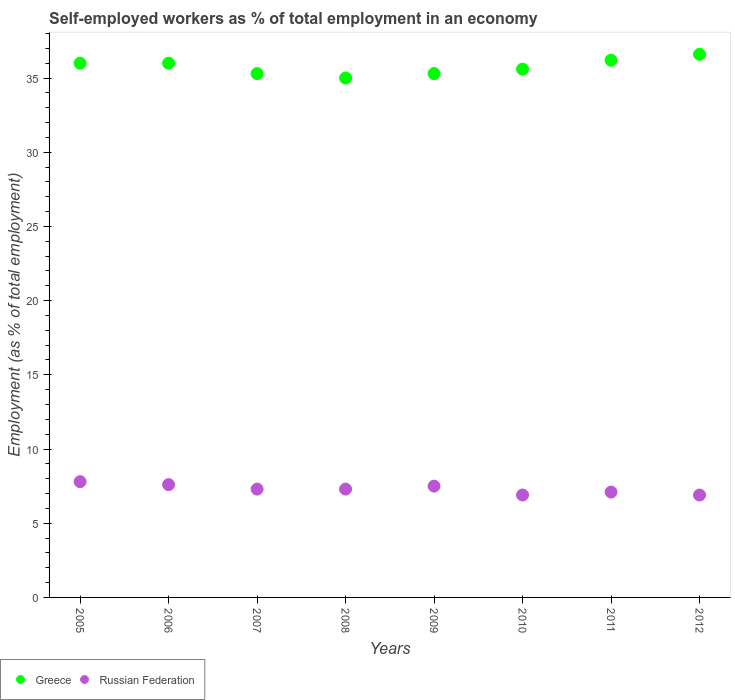How many different coloured dotlines are there?
Ensure brevity in your answer.  2. Is the number of dotlines equal to the number of legend labels?
Provide a short and direct response. Yes. What is the percentage of self-employed workers in Russian Federation in 2005?
Your response must be concise. 7.8. Across all years, what is the maximum percentage of self-employed workers in Russian Federation?
Offer a very short reply. 7.8. Across all years, what is the minimum percentage of self-employed workers in Greece?
Give a very brief answer. 35. In which year was the percentage of self-employed workers in Russian Federation minimum?
Give a very brief answer. 2010. What is the total percentage of self-employed workers in Greece in the graph?
Provide a succinct answer. 286. What is the difference between the percentage of self-employed workers in Russian Federation in 2007 and that in 2012?
Give a very brief answer. 0.4. What is the difference between the percentage of self-employed workers in Greece in 2011 and the percentage of self-employed workers in Russian Federation in 2009?
Provide a succinct answer. 28.7. What is the average percentage of self-employed workers in Greece per year?
Keep it short and to the point. 35.75. In the year 2009, what is the difference between the percentage of self-employed workers in Greece and percentage of self-employed workers in Russian Federation?
Keep it short and to the point. 27.8. In how many years, is the percentage of self-employed workers in Greece greater than 17 %?
Your answer should be very brief. 8. What is the ratio of the percentage of self-employed workers in Greece in 2005 to that in 2008?
Provide a succinct answer. 1.03. What is the difference between the highest and the second highest percentage of self-employed workers in Russian Federation?
Keep it short and to the point. 0.2. What is the difference between the highest and the lowest percentage of self-employed workers in Russian Federation?
Your response must be concise. 0.9. Does the percentage of self-employed workers in Russian Federation monotonically increase over the years?
Ensure brevity in your answer.  No. Is the percentage of self-employed workers in Greece strictly less than the percentage of self-employed workers in Russian Federation over the years?
Offer a very short reply. No. What is the difference between two consecutive major ticks on the Y-axis?
Make the answer very short. 5. Does the graph contain any zero values?
Provide a short and direct response. No. How are the legend labels stacked?
Provide a succinct answer. Horizontal. What is the title of the graph?
Offer a very short reply. Self-employed workers as % of total employment in an economy. Does "Djibouti" appear as one of the legend labels in the graph?
Make the answer very short. No. What is the label or title of the X-axis?
Your answer should be very brief. Years. What is the label or title of the Y-axis?
Give a very brief answer. Employment (as % of total employment). What is the Employment (as % of total employment) of Greece in 2005?
Provide a short and direct response. 36. What is the Employment (as % of total employment) of Russian Federation in 2005?
Give a very brief answer. 7.8. What is the Employment (as % of total employment) in Russian Federation in 2006?
Your response must be concise. 7.6. What is the Employment (as % of total employment) of Greece in 2007?
Provide a short and direct response. 35.3. What is the Employment (as % of total employment) of Russian Federation in 2007?
Your answer should be very brief. 7.3. What is the Employment (as % of total employment) of Greece in 2008?
Your answer should be compact. 35. What is the Employment (as % of total employment) of Russian Federation in 2008?
Keep it short and to the point. 7.3. What is the Employment (as % of total employment) of Greece in 2009?
Your answer should be compact. 35.3. What is the Employment (as % of total employment) in Greece in 2010?
Offer a very short reply. 35.6. What is the Employment (as % of total employment) of Russian Federation in 2010?
Your answer should be compact. 6.9. What is the Employment (as % of total employment) in Greece in 2011?
Offer a terse response. 36.2. What is the Employment (as % of total employment) in Russian Federation in 2011?
Give a very brief answer. 7.1. What is the Employment (as % of total employment) of Greece in 2012?
Offer a very short reply. 36.6. What is the Employment (as % of total employment) of Russian Federation in 2012?
Your answer should be compact. 6.9. Across all years, what is the maximum Employment (as % of total employment) in Greece?
Your answer should be compact. 36.6. Across all years, what is the maximum Employment (as % of total employment) in Russian Federation?
Your answer should be very brief. 7.8. Across all years, what is the minimum Employment (as % of total employment) in Russian Federation?
Offer a very short reply. 6.9. What is the total Employment (as % of total employment) in Greece in the graph?
Give a very brief answer. 286. What is the total Employment (as % of total employment) of Russian Federation in the graph?
Your response must be concise. 58.4. What is the difference between the Employment (as % of total employment) of Russian Federation in 2005 and that in 2006?
Offer a terse response. 0.2. What is the difference between the Employment (as % of total employment) in Russian Federation in 2005 and that in 2007?
Provide a succinct answer. 0.5. What is the difference between the Employment (as % of total employment) in Russian Federation in 2005 and that in 2008?
Offer a terse response. 0.5. What is the difference between the Employment (as % of total employment) of Greece in 2005 and that in 2009?
Keep it short and to the point. 0.7. What is the difference between the Employment (as % of total employment) of Russian Federation in 2005 and that in 2009?
Provide a succinct answer. 0.3. What is the difference between the Employment (as % of total employment) in Russian Federation in 2005 and that in 2010?
Your response must be concise. 0.9. What is the difference between the Employment (as % of total employment) of Russian Federation in 2005 and that in 2012?
Make the answer very short. 0.9. What is the difference between the Employment (as % of total employment) in Greece in 2006 and that in 2007?
Ensure brevity in your answer.  0.7. What is the difference between the Employment (as % of total employment) in Russian Federation in 2006 and that in 2007?
Offer a very short reply. 0.3. What is the difference between the Employment (as % of total employment) of Greece in 2006 and that in 2008?
Keep it short and to the point. 1. What is the difference between the Employment (as % of total employment) in Greece in 2006 and that in 2009?
Give a very brief answer. 0.7. What is the difference between the Employment (as % of total employment) in Russian Federation in 2006 and that in 2009?
Provide a short and direct response. 0.1. What is the difference between the Employment (as % of total employment) of Russian Federation in 2006 and that in 2010?
Ensure brevity in your answer.  0.7. What is the difference between the Employment (as % of total employment) in Greece in 2006 and that in 2011?
Your answer should be compact. -0.2. What is the difference between the Employment (as % of total employment) of Greece in 2006 and that in 2012?
Ensure brevity in your answer.  -0.6. What is the difference between the Employment (as % of total employment) in Russian Federation in 2006 and that in 2012?
Ensure brevity in your answer.  0.7. What is the difference between the Employment (as % of total employment) in Russian Federation in 2007 and that in 2010?
Offer a terse response. 0.4. What is the difference between the Employment (as % of total employment) of Greece in 2007 and that in 2011?
Your response must be concise. -0.9. What is the difference between the Employment (as % of total employment) in Russian Federation in 2007 and that in 2011?
Your answer should be compact. 0.2. What is the difference between the Employment (as % of total employment) in Russian Federation in 2007 and that in 2012?
Provide a succinct answer. 0.4. What is the difference between the Employment (as % of total employment) in Greece in 2008 and that in 2009?
Provide a succinct answer. -0.3. What is the difference between the Employment (as % of total employment) of Russian Federation in 2008 and that in 2009?
Your answer should be very brief. -0.2. What is the difference between the Employment (as % of total employment) of Greece in 2008 and that in 2011?
Ensure brevity in your answer.  -1.2. What is the difference between the Employment (as % of total employment) in Russian Federation in 2008 and that in 2011?
Provide a short and direct response. 0.2. What is the difference between the Employment (as % of total employment) in Greece in 2008 and that in 2012?
Ensure brevity in your answer.  -1.6. What is the difference between the Employment (as % of total employment) of Russian Federation in 2008 and that in 2012?
Make the answer very short. 0.4. What is the difference between the Employment (as % of total employment) of Greece in 2009 and that in 2010?
Ensure brevity in your answer.  -0.3. What is the difference between the Employment (as % of total employment) of Greece in 2009 and that in 2011?
Make the answer very short. -0.9. What is the difference between the Employment (as % of total employment) of Russian Federation in 2009 and that in 2011?
Give a very brief answer. 0.4. What is the difference between the Employment (as % of total employment) of Greece in 2009 and that in 2012?
Make the answer very short. -1.3. What is the difference between the Employment (as % of total employment) of Russian Federation in 2009 and that in 2012?
Your answer should be very brief. 0.6. What is the difference between the Employment (as % of total employment) of Greece in 2010 and that in 2011?
Make the answer very short. -0.6. What is the difference between the Employment (as % of total employment) in Russian Federation in 2010 and that in 2012?
Your answer should be very brief. 0. What is the difference between the Employment (as % of total employment) of Russian Federation in 2011 and that in 2012?
Offer a terse response. 0.2. What is the difference between the Employment (as % of total employment) of Greece in 2005 and the Employment (as % of total employment) of Russian Federation in 2006?
Give a very brief answer. 28.4. What is the difference between the Employment (as % of total employment) in Greece in 2005 and the Employment (as % of total employment) in Russian Federation in 2007?
Offer a terse response. 28.7. What is the difference between the Employment (as % of total employment) of Greece in 2005 and the Employment (as % of total employment) of Russian Federation in 2008?
Offer a terse response. 28.7. What is the difference between the Employment (as % of total employment) of Greece in 2005 and the Employment (as % of total employment) of Russian Federation in 2009?
Provide a succinct answer. 28.5. What is the difference between the Employment (as % of total employment) of Greece in 2005 and the Employment (as % of total employment) of Russian Federation in 2010?
Make the answer very short. 29.1. What is the difference between the Employment (as % of total employment) in Greece in 2005 and the Employment (as % of total employment) in Russian Federation in 2011?
Offer a very short reply. 28.9. What is the difference between the Employment (as % of total employment) in Greece in 2005 and the Employment (as % of total employment) in Russian Federation in 2012?
Offer a very short reply. 29.1. What is the difference between the Employment (as % of total employment) in Greece in 2006 and the Employment (as % of total employment) in Russian Federation in 2007?
Offer a terse response. 28.7. What is the difference between the Employment (as % of total employment) in Greece in 2006 and the Employment (as % of total employment) in Russian Federation in 2008?
Ensure brevity in your answer.  28.7. What is the difference between the Employment (as % of total employment) in Greece in 2006 and the Employment (as % of total employment) in Russian Federation in 2010?
Give a very brief answer. 29.1. What is the difference between the Employment (as % of total employment) in Greece in 2006 and the Employment (as % of total employment) in Russian Federation in 2011?
Your answer should be very brief. 28.9. What is the difference between the Employment (as % of total employment) of Greece in 2006 and the Employment (as % of total employment) of Russian Federation in 2012?
Provide a succinct answer. 29.1. What is the difference between the Employment (as % of total employment) in Greece in 2007 and the Employment (as % of total employment) in Russian Federation in 2009?
Make the answer very short. 27.8. What is the difference between the Employment (as % of total employment) in Greece in 2007 and the Employment (as % of total employment) in Russian Federation in 2010?
Ensure brevity in your answer.  28.4. What is the difference between the Employment (as % of total employment) of Greece in 2007 and the Employment (as % of total employment) of Russian Federation in 2011?
Offer a terse response. 28.2. What is the difference between the Employment (as % of total employment) of Greece in 2007 and the Employment (as % of total employment) of Russian Federation in 2012?
Your response must be concise. 28.4. What is the difference between the Employment (as % of total employment) in Greece in 2008 and the Employment (as % of total employment) in Russian Federation in 2010?
Provide a succinct answer. 28.1. What is the difference between the Employment (as % of total employment) of Greece in 2008 and the Employment (as % of total employment) of Russian Federation in 2011?
Provide a succinct answer. 27.9. What is the difference between the Employment (as % of total employment) in Greece in 2008 and the Employment (as % of total employment) in Russian Federation in 2012?
Keep it short and to the point. 28.1. What is the difference between the Employment (as % of total employment) in Greece in 2009 and the Employment (as % of total employment) in Russian Federation in 2010?
Make the answer very short. 28.4. What is the difference between the Employment (as % of total employment) of Greece in 2009 and the Employment (as % of total employment) of Russian Federation in 2011?
Your answer should be very brief. 28.2. What is the difference between the Employment (as % of total employment) of Greece in 2009 and the Employment (as % of total employment) of Russian Federation in 2012?
Make the answer very short. 28.4. What is the difference between the Employment (as % of total employment) of Greece in 2010 and the Employment (as % of total employment) of Russian Federation in 2011?
Keep it short and to the point. 28.5. What is the difference between the Employment (as % of total employment) of Greece in 2010 and the Employment (as % of total employment) of Russian Federation in 2012?
Offer a terse response. 28.7. What is the difference between the Employment (as % of total employment) in Greece in 2011 and the Employment (as % of total employment) in Russian Federation in 2012?
Provide a succinct answer. 29.3. What is the average Employment (as % of total employment) in Greece per year?
Your response must be concise. 35.75. What is the average Employment (as % of total employment) in Russian Federation per year?
Offer a very short reply. 7.3. In the year 2005, what is the difference between the Employment (as % of total employment) of Greece and Employment (as % of total employment) of Russian Federation?
Ensure brevity in your answer.  28.2. In the year 2006, what is the difference between the Employment (as % of total employment) in Greece and Employment (as % of total employment) in Russian Federation?
Ensure brevity in your answer.  28.4. In the year 2007, what is the difference between the Employment (as % of total employment) in Greece and Employment (as % of total employment) in Russian Federation?
Offer a very short reply. 28. In the year 2008, what is the difference between the Employment (as % of total employment) of Greece and Employment (as % of total employment) of Russian Federation?
Offer a terse response. 27.7. In the year 2009, what is the difference between the Employment (as % of total employment) in Greece and Employment (as % of total employment) in Russian Federation?
Offer a very short reply. 27.8. In the year 2010, what is the difference between the Employment (as % of total employment) in Greece and Employment (as % of total employment) in Russian Federation?
Make the answer very short. 28.7. In the year 2011, what is the difference between the Employment (as % of total employment) in Greece and Employment (as % of total employment) in Russian Federation?
Provide a short and direct response. 29.1. In the year 2012, what is the difference between the Employment (as % of total employment) in Greece and Employment (as % of total employment) in Russian Federation?
Keep it short and to the point. 29.7. What is the ratio of the Employment (as % of total employment) of Greece in 2005 to that in 2006?
Provide a short and direct response. 1. What is the ratio of the Employment (as % of total employment) in Russian Federation in 2005 to that in 2006?
Make the answer very short. 1.03. What is the ratio of the Employment (as % of total employment) of Greece in 2005 to that in 2007?
Your response must be concise. 1.02. What is the ratio of the Employment (as % of total employment) in Russian Federation in 2005 to that in 2007?
Your answer should be compact. 1.07. What is the ratio of the Employment (as % of total employment) of Greece in 2005 to that in 2008?
Offer a very short reply. 1.03. What is the ratio of the Employment (as % of total employment) of Russian Federation in 2005 to that in 2008?
Your answer should be very brief. 1.07. What is the ratio of the Employment (as % of total employment) of Greece in 2005 to that in 2009?
Make the answer very short. 1.02. What is the ratio of the Employment (as % of total employment) in Greece in 2005 to that in 2010?
Make the answer very short. 1.01. What is the ratio of the Employment (as % of total employment) in Russian Federation in 2005 to that in 2010?
Ensure brevity in your answer.  1.13. What is the ratio of the Employment (as % of total employment) of Russian Federation in 2005 to that in 2011?
Provide a succinct answer. 1.1. What is the ratio of the Employment (as % of total employment) of Greece in 2005 to that in 2012?
Make the answer very short. 0.98. What is the ratio of the Employment (as % of total employment) of Russian Federation in 2005 to that in 2012?
Provide a succinct answer. 1.13. What is the ratio of the Employment (as % of total employment) in Greece in 2006 to that in 2007?
Keep it short and to the point. 1.02. What is the ratio of the Employment (as % of total employment) in Russian Federation in 2006 to that in 2007?
Provide a short and direct response. 1.04. What is the ratio of the Employment (as % of total employment) of Greece in 2006 to that in 2008?
Give a very brief answer. 1.03. What is the ratio of the Employment (as % of total employment) of Russian Federation in 2006 to that in 2008?
Provide a short and direct response. 1.04. What is the ratio of the Employment (as % of total employment) in Greece in 2006 to that in 2009?
Provide a short and direct response. 1.02. What is the ratio of the Employment (as % of total employment) in Russian Federation in 2006 to that in 2009?
Your answer should be compact. 1.01. What is the ratio of the Employment (as % of total employment) of Greece in 2006 to that in 2010?
Provide a short and direct response. 1.01. What is the ratio of the Employment (as % of total employment) of Russian Federation in 2006 to that in 2010?
Your response must be concise. 1.1. What is the ratio of the Employment (as % of total employment) in Russian Federation in 2006 to that in 2011?
Your response must be concise. 1.07. What is the ratio of the Employment (as % of total employment) in Greece in 2006 to that in 2012?
Give a very brief answer. 0.98. What is the ratio of the Employment (as % of total employment) of Russian Federation in 2006 to that in 2012?
Provide a succinct answer. 1.1. What is the ratio of the Employment (as % of total employment) in Greece in 2007 to that in 2008?
Your answer should be compact. 1.01. What is the ratio of the Employment (as % of total employment) of Greece in 2007 to that in 2009?
Give a very brief answer. 1. What is the ratio of the Employment (as % of total employment) in Russian Federation in 2007 to that in 2009?
Offer a very short reply. 0.97. What is the ratio of the Employment (as % of total employment) in Greece in 2007 to that in 2010?
Ensure brevity in your answer.  0.99. What is the ratio of the Employment (as % of total employment) in Russian Federation in 2007 to that in 2010?
Provide a short and direct response. 1.06. What is the ratio of the Employment (as % of total employment) of Greece in 2007 to that in 2011?
Make the answer very short. 0.98. What is the ratio of the Employment (as % of total employment) in Russian Federation in 2007 to that in 2011?
Provide a succinct answer. 1.03. What is the ratio of the Employment (as % of total employment) of Greece in 2007 to that in 2012?
Keep it short and to the point. 0.96. What is the ratio of the Employment (as % of total employment) of Russian Federation in 2007 to that in 2012?
Provide a short and direct response. 1.06. What is the ratio of the Employment (as % of total employment) of Russian Federation in 2008 to that in 2009?
Your answer should be compact. 0.97. What is the ratio of the Employment (as % of total employment) in Greece in 2008 to that in 2010?
Provide a short and direct response. 0.98. What is the ratio of the Employment (as % of total employment) in Russian Federation in 2008 to that in 2010?
Make the answer very short. 1.06. What is the ratio of the Employment (as % of total employment) in Greece in 2008 to that in 2011?
Keep it short and to the point. 0.97. What is the ratio of the Employment (as % of total employment) in Russian Federation in 2008 to that in 2011?
Make the answer very short. 1.03. What is the ratio of the Employment (as % of total employment) in Greece in 2008 to that in 2012?
Offer a terse response. 0.96. What is the ratio of the Employment (as % of total employment) in Russian Federation in 2008 to that in 2012?
Give a very brief answer. 1.06. What is the ratio of the Employment (as % of total employment) in Russian Federation in 2009 to that in 2010?
Your response must be concise. 1.09. What is the ratio of the Employment (as % of total employment) in Greece in 2009 to that in 2011?
Offer a very short reply. 0.98. What is the ratio of the Employment (as % of total employment) of Russian Federation in 2009 to that in 2011?
Ensure brevity in your answer.  1.06. What is the ratio of the Employment (as % of total employment) in Greece in 2009 to that in 2012?
Keep it short and to the point. 0.96. What is the ratio of the Employment (as % of total employment) in Russian Federation in 2009 to that in 2012?
Your response must be concise. 1.09. What is the ratio of the Employment (as % of total employment) in Greece in 2010 to that in 2011?
Ensure brevity in your answer.  0.98. What is the ratio of the Employment (as % of total employment) of Russian Federation in 2010 to that in 2011?
Provide a short and direct response. 0.97. What is the ratio of the Employment (as % of total employment) of Greece in 2010 to that in 2012?
Offer a very short reply. 0.97. What is the ratio of the Employment (as % of total employment) in Russian Federation in 2010 to that in 2012?
Keep it short and to the point. 1. What is the ratio of the Employment (as % of total employment) of Greece in 2011 to that in 2012?
Make the answer very short. 0.99. What is the ratio of the Employment (as % of total employment) of Russian Federation in 2011 to that in 2012?
Offer a very short reply. 1.03. What is the difference between the highest and the lowest Employment (as % of total employment) of Greece?
Provide a short and direct response. 1.6. 